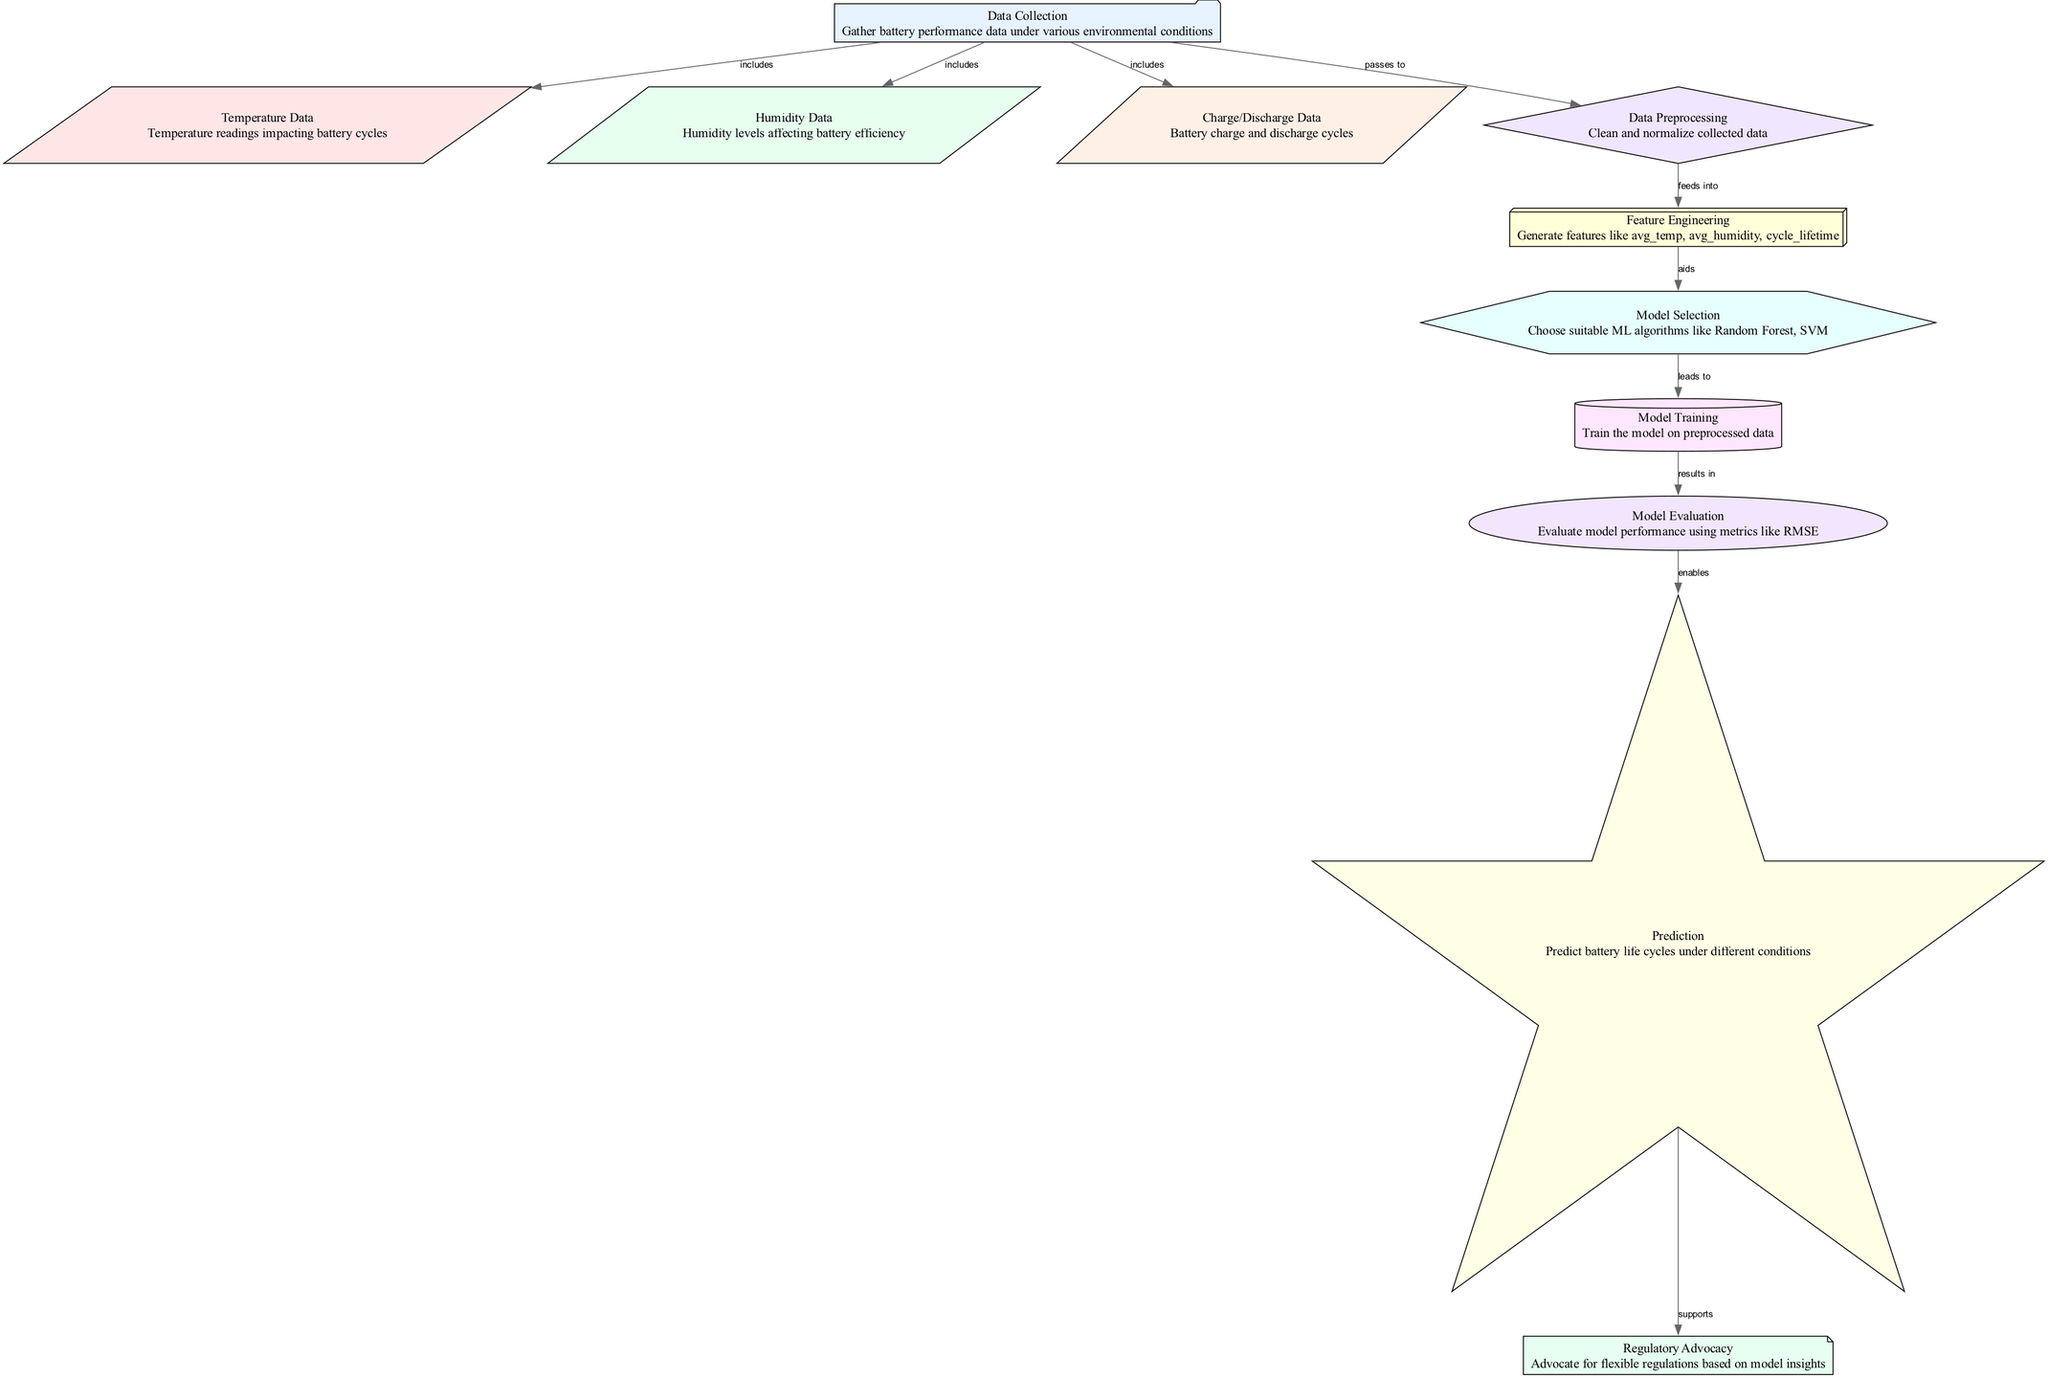What is the first node in the diagram? The diagram starts with the "Data Collection" node, which is labeled as the first step in the process.
Answer: Data Collection How many environmental data nodes are included? There are three environmental data nodes: "Temperature Data," "Humidity Data," and "Charge/Discharge Data."
Answer: Three Which node processes the data after collection? The data collected from the previous nodes passes to the "Data Preprocessing" node for cleaning and normalization.
Answer: Data Preprocessing What relationship exists between the "Model Evaluation" and "Prediction" nodes? The "Model Evaluation" node enables the "Prediction" node, creating a flow from evaluating model performance to making predictions about battery life.
Answer: Enables Which node supports regulatory advocacy? The "Prediction" node supports "Regulatory Advocacy," indicating how predictions can influence regulatory discussions.
Answer: Prediction What type of algorithm might be selected in the "Model Selection" node? The "Model Selection" node may choose algorithms like Random Forest or SVM.
Answer: Random Forest or SVM What does the "Feature Engineering" node generate? The "Feature Engineering" node generates features like average temperature, average humidity, and cycle lifetime.
Answer: Features How does "Data Preprocessing" contribute to "Feature Engineering"? The cleaned and normalized data from "Data Preprocessing" feeds into "Feature Engineering," aiding in the generation of new features.
Answer: Feeds into What is the overall goal of the diagram? The overall goal of the diagram is to predict battery life cycles under different environmental conditions, using the insights gained through the model development process.
Answer: Predict battery life cycles 